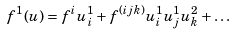Convert formula to latex. <formula><loc_0><loc_0><loc_500><loc_500>f ^ { 1 } ( u ) = f ^ { i } u ^ { 1 } _ { i } + f ^ { ( i j k ) } u ^ { 1 } _ { i } u ^ { 1 } _ { j } u ^ { 2 } _ { k } + \dots</formula> 